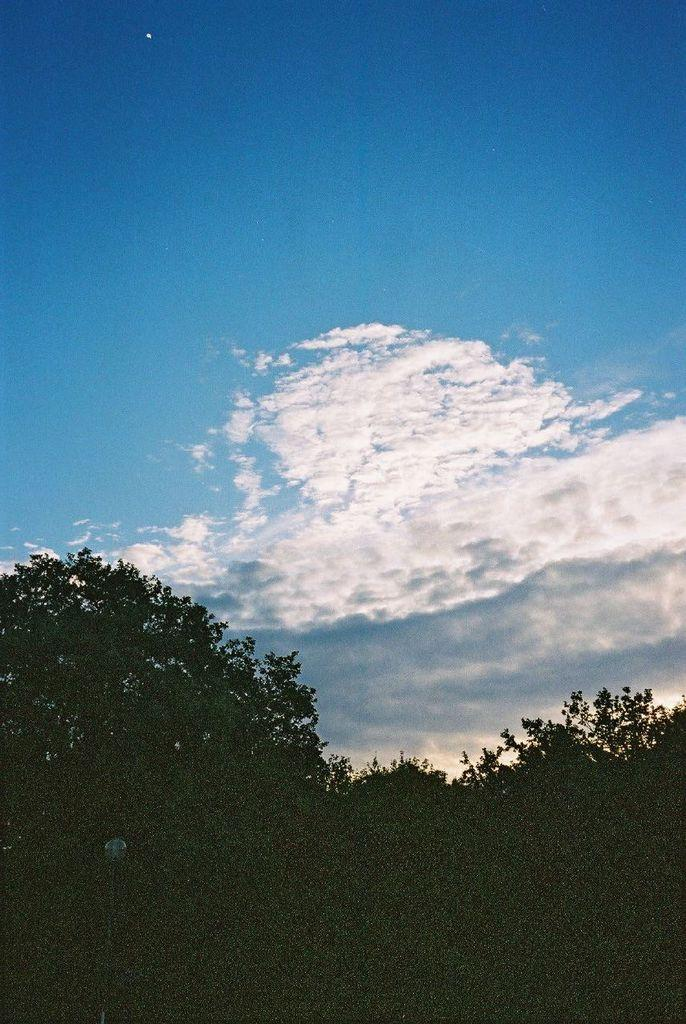What type of vegetation is at the bottom of the image? There are trees at the bottom of the image. What can be seen in the sky in the image? Clouds are visible in the image. What else is visible in the sky besides clouds? The sky is visible in the image. How many divisions can be seen in the clouds in the image? There is no mention of divisions in the clouds in the image, and therefore it cannot be determined. What type of foot is visible in the image? There is no foot present in the image. 